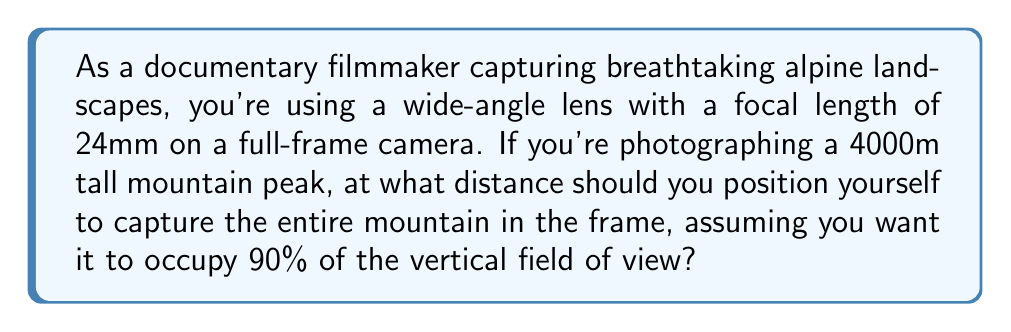Provide a solution to this math problem. Let's approach this step-by-step:

1) First, we need to calculate the vertical field of view (FOV) for a 24mm lens on a full-frame camera.

   The formula for vertical FOV is:
   $$ \text{FOV}_v = 2 \arctan\left(\frac{h}{2f}\right) $$
   where $h$ is the height of the sensor (24mm for full-frame) and $f$ is the focal length.

   $$ \text{FOV}_v = 2 \arctan\left(\frac{24}{2 \cdot 24}\right) = 2 \arctan(0.5) \approx 53.13° $$

2) Now, we want the 4000m mountain to occupy 90% of this vertical FOV. So the effective FOV we're working with is:
   $$ 53.13° \cdot 0.90 = 47.82° $$

3) We can now use trigonometry to find the distance. If we draw a line from the camera to the top and bottom of the mountain, it forms a right triangle where:
   - The opposite side is the height of the mountain (4000m)
   - The angle at the camera is our effective FOV (47.82°)
   - We need to find the adjacent side (the distance from the camera to the mountain)

4) Using the tangent function:
   $$ \tan\left(\frac{47.82°}{2}\right) = \frac{2000}{d} $$
   where $d$ is the distance we're looking for.

5) Solving for $d$:
   $$ d = \frac{2000}{\tan(23.91°)} \approx 4432.69 \text{ meters} $$

[asy]
import geometry;

size(200);
pair A = (0,0), B = (100,0), C = (100,90);
draw(A--B--C--A);
label("Camera", A, SW);
label("4000m", C, E);
label("d", (50,0), S);
label("47.82°", A, NE);
[/asy]
Answer: $$4432.69 \text{ meters}$$ 